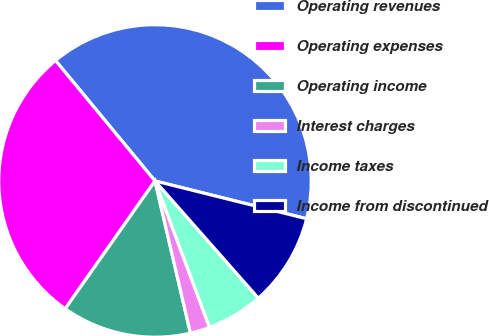Convert chart to OTSL. <chart><loc_0><loc_0><loc_500><loc_500><pie_chart><fcel>Operating revenues<fcel>Operating expenses<fcel>Operating income<fcel>Interest charges<fcel>Income taxes<fcel>Income from discontinued<nl><fcel>39.88%<fcel>29.26%<fcel>13.39%<fcel>2.04%<fcel>5.82%<fcel>9.61%<nl></chart> 